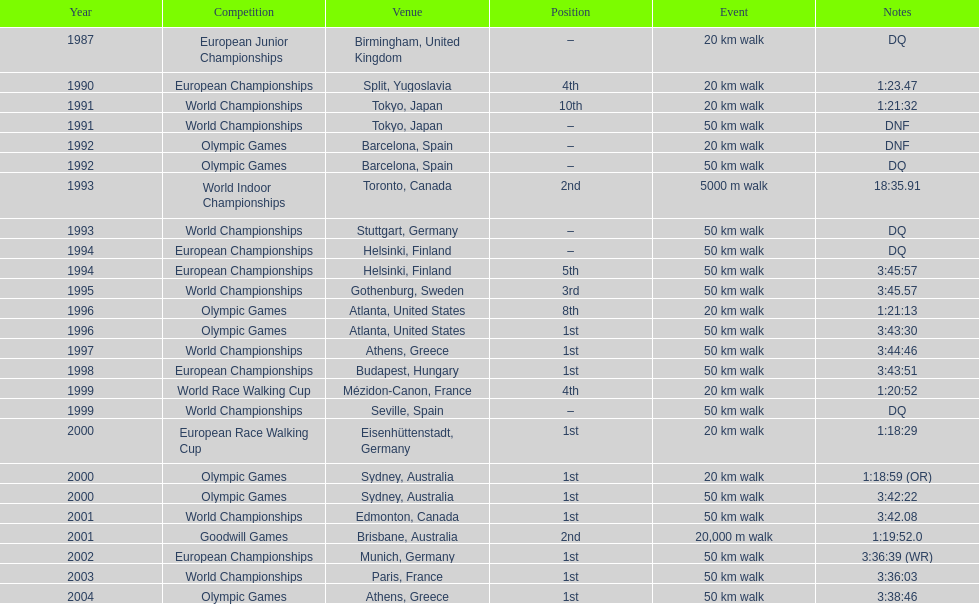Which venue is listed the most? Athens, Greece. 